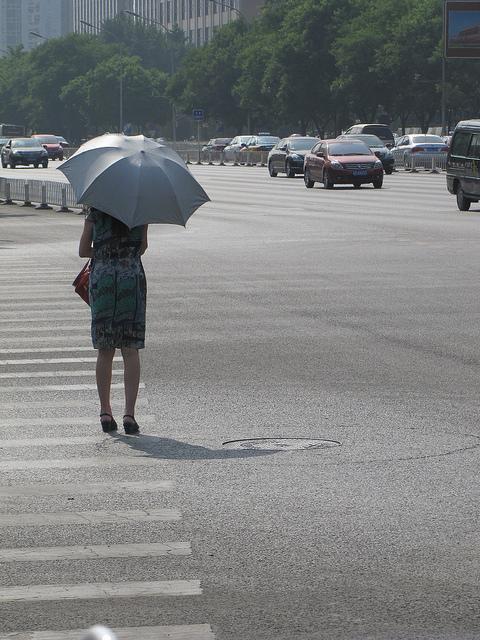How many cars are in the photo?
Give a very brief answer. 2. How many bottles of orange soda appear in this picture?
Give a very brief answer. 0. 